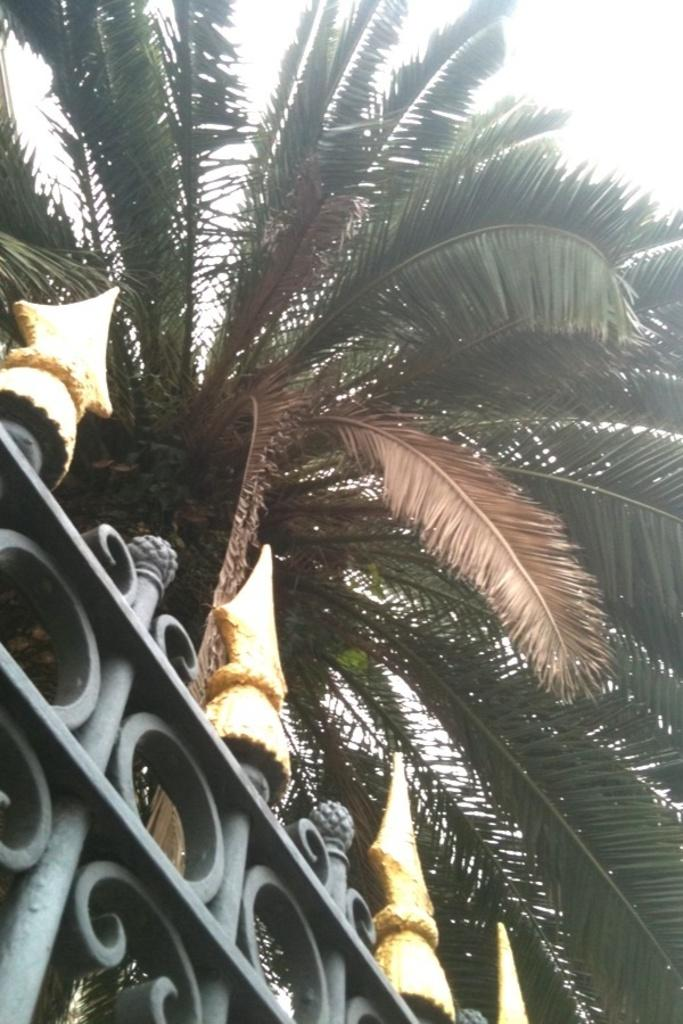What structure can be seen in the image? There is a gate in the image. What type of plant is present in the image? There is a tree in the image. What color is the background of the image? The background of the image is white. What color is the paint on the tree's toe in the image? There is no paint or toe present on the tree in the image. 